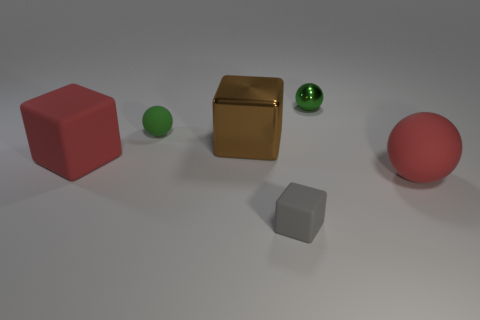What textures or finishes are present on the objects in this image? In the image, the textures and finishes vary among the objects. The spheres have a smooth, reflective surface, with the green sphere to the left of the brown block appearing matte, while the other green and the red sphere are shiny. The cubes display a matte finish, and the brown block in the center has a reflective metallic texture.  Based on the shadows, what can you infer about the light source? Observing the shadows cast by the objects, it appears that the primary light source is coming from above and slightly to the left. The shadows are angled toward the lower right side of the image, which suggests that the light source is situated to the upper left of the frame, diagonally from the objects. 